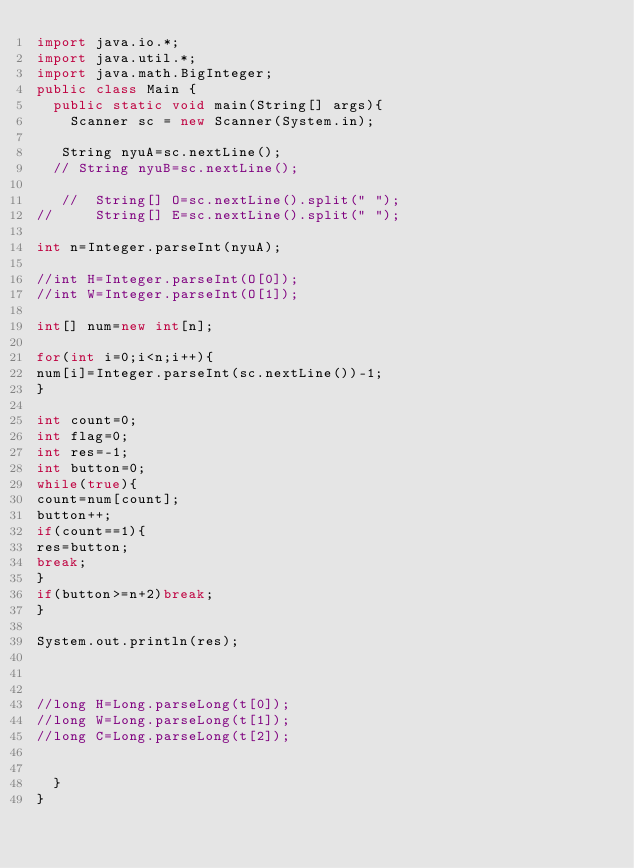Convert code to text. <code><loc_0><loc_0><loc_500><loc_500><_Java_>import java.io.*;
import java.util.*;
import java.math.BigInteger;
public class Main {
	public static void main(String[] args){
		Scanner sc = new Scanner(System.in);

   String nyuA=sc.nextLine();
  // String nyuB=sc.nextLine();
 
   //  String[] O=sc.nextLine().split(" ");
//     String[] E=sc.nextLine().split(" ");

int n=Integer.parseInt(nyuA);

//int H=Integer.parseInt(O[0]);
//int W=Integer.parseInt(O[1]);

int[] num=new int[n];

for(int i=0;i<n;i++){
num[i]=Integer.parseInt(sc.nextLine())-1;
}

int count=0;
int flag=0;
int res=-1;
int button=0;
while(true){
count=num[count];
button++;
if(count==1){
res=button;
break;
}
if(button>=n+2)break;
}

System.out.println(res);



//long H=Long.parseLong(t[0]);
//long W=Long.parseLong(t[1]);
//long C=Long.parseLong(t[2]);


	}
}</code> 